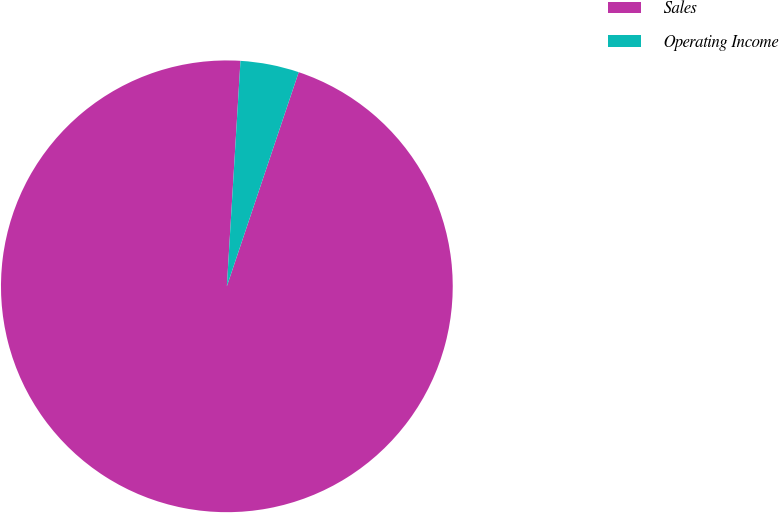<chart> <loc_0><loc_0><loc_500><loc_500><pie_chart><fcel>Sales<fcel>Operating Income<nl><fcel>95.81%<fcel>4.19%<nl></chart> 